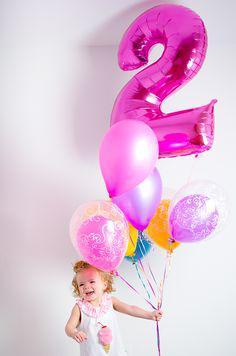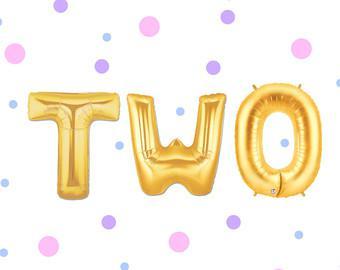The first image is the image on the left, the second image is the image on the right. Assess this claim about the two images: "One of the balloons is shaped like the number 2.". Correct or not? Answer yes or no. Yes. The first image is the image on the left, the second image is the image on the right. For the images shown, is this caption "One image shows a balloon shaped like the number 2, along with other balloons." true? Answer yes or no. Yes. 